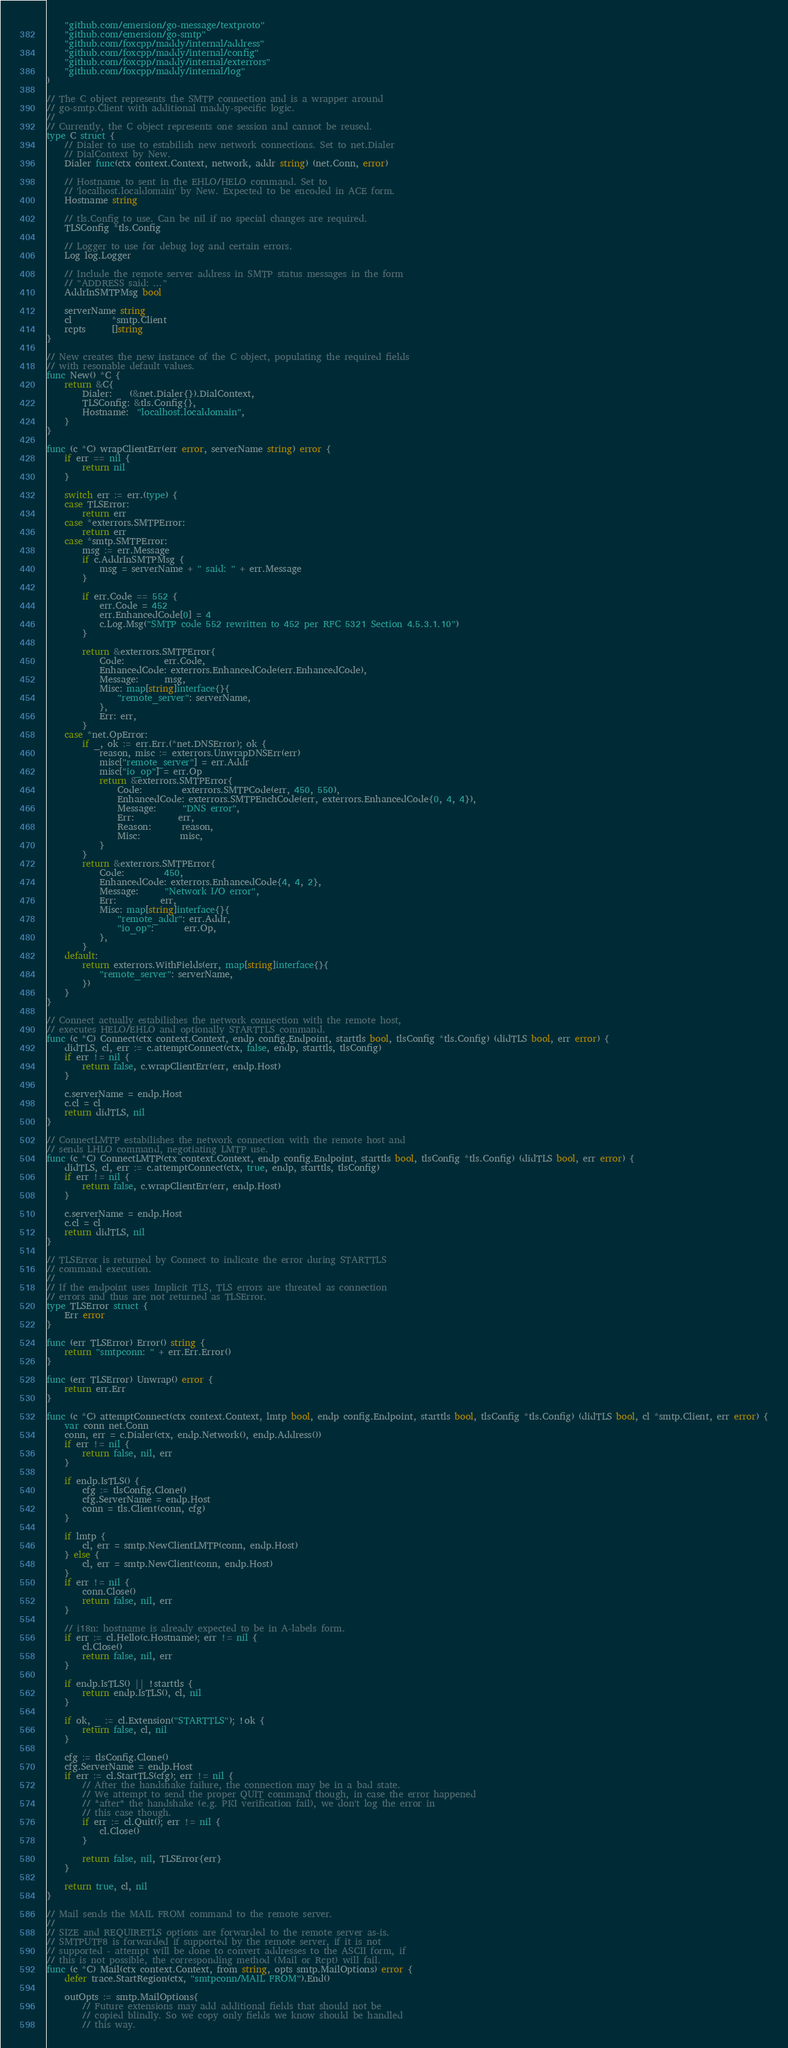<code> <loc_0><loc_0><loc_500><loc_500><_Go_>	"github.com/emersion/go-message/textproto"
	"github.com/emersion/go-smtp"
	"github.com/foxcpp/maddy/internal/address"
	"github.com/foxcpp/maddy/internal/config"
	"github.com/foxcpp/maddy/internal/exterrors"
	"github.com/foxcpp/maddy/internal/log"
)

// The C object represents the SMTP connection and is a wrapper around
// go-smtp.Client with additional maddy-specific logic.
//
// Currently, the C object represents one session and cannot be reused.
type C struct {
	// Dialer to use to estabilish new network connections. Set to net.Dialer
	// DialContext by New.
	Dialer func(ctx context.Context, network, addr string) (net.Conn, error)

	// Hostname to sent in the EHLO/HELO command. Set to
	// 'localhost.localdomain' by New. Expected to be encoded in ACE form.
	Hostname string

	// tls.Config to use. Can be nil if no special changes are required.
	TLSConfig *tls.Config

	// Logger to use for debug log and certain errors.
	Log log.Logger

	// Include the remote server address in SMTP status messages in the form
	// "ADDRESS said: ..."
	AddrInSMTPMsg bool

	serverName string
	cl         *smtp.Client
	rcpts      []string
}

// New creates the new instance of the C object, populating the required fields
// with resonable default values.
func New() *C {
	return &C{
		Dialer:    (&net.Dialer{}).DialContext,
		TLSConfig: &tls.Config{},
		Hostname:  "localhost.localdomain",
	}
}

func (c *C) wrapClientErr(err error, serverName string) error {
	if err == nil {
		return nil
	}

	switch err := err.(type) {
	case TLSError:
		return err
	case *exterrors.SMTPError:
		return err
	case *smtp.SMTPError:
		msg := err.Message
		if c.AddrInSMTPMsg {
			msg = serverName + " said: " + err.Message
		}

		if err.Code == 552 {
			err.Code = 452
			err.EnhancedCode[0] = 4
			c.Log.Msg("SMTP code 552 rewritten to 452 per RFC 5321 Section 4.5.3.1.10")
		}

		return &exterrors.SMTPError{
			Code:         err.Code,
			EnhancedCode: exterrors.EnhancedCode(err.EnhancedCode),
			Message:      msg,
			Misc: map[string]interface{}{
				"remote_server": serverName,
			},
			Err: err,
		}
	case *net.OpError:
		if _, ok := err.Err.(*net.DNSError); ok {
			reason, misc := exterrors.UnwrapDNSErr(err)
			misc["remote_server"] = err.Addr
			misc["io_op"] = err.Op
			return &exterrors.SMTPError{
				Code:         exterrors.SMTPCode(err, 450, 550),
				EnhancedCode: exterrors.SMTPEnchCode(err, exterrors.EnhancedCode{0, 4, 4}),
				Message:      "DNS error",
				Err:          err,
				Reason:       reason,
				Misc:         misc,
			}
		}
		return &exterrors.SMTPError{
			Code:         450,
			EnhancedCode: exterrors.EnhancedCode{4, 4, 2},
			Message:      "Network I/O error",
			Err:          err,
			Misc: map[string]interface{}{
				"remote_addr": err.Addr,
				"io_op":       err.Op,
			},
		}
	default:
		return exterrors.WithFields(err, map[string]interface{}{
			"remote_server": serverName,
		})
	}
}

// Connect actually estabilishes the network connection with the remote host,
// executes HELO/EHLO and optionally STARTTLS command.
func (c *C) Connect(ctx context.Context, endp config.Endpoint, starttls bool, tlsConfig *tls.Config) (didTLS bool, err error) {
	didTLS, cl, err := c.attemptConnect(ctx, false, endp, starttls, tlsConfig)
	if err != nil {
		return false, c.wrapClientErr(err, endp.Host)
	}

	c.serverName = endp.Host
	c.cl = cl
	return didTLS, nil
}

// ConnectLMTP estabilishes the network connection with the remote host and
// sends LHLO command, negotiating LMTP use.
func (c *C) ConnectLMTP(ctx context.Context, endp config.Endpoint, starttls bool, tlsConfig *tls.Config) (didTLS bool, err error) {
	didTLS, cl, err := c.attemptConnect(ctx, true, endp, starttls, tlsConfig)
	if err != nil {
		return false, c.wrapClientErr(err, endp.Host)
	}

	c.serverName = endp.Host
	c.cl = cl
	return didTLS, nil
}

// TLSError is returned by Connect to indicate the error during STARTTLS
// command execution.
//
// If the endpoint uses Implicit TLS, TLS errors are threated as connection
// errors and thus are not returned as TLSError.
type TLSError struct {
	Err error
}

func (err TLSError) Error() string {
	return "smtpconn: " + err.Err.Error()
}

func (err TLSError) Unwrap() error {
	return err.Err
}

func (c *C) attemptConnect(ctx context.Context, lmtp bool, endp config.Endpoint, starttls bool, tlsConfig *tls.Config) (didTLS bool, cl *smtp.Client, err error) {
	var conn net.Conn
	conn, err = c.Dialer(ctx, endp.Network(), endp.Address())
	if err != nil {
		return false, nil, err
	}

	if endp.IsTLS() {
		cfg := tlsConfig.Clone()
		cfg.ServerName = endp.Host
		conn = tls.Client(conn, cfg)
	}

	if lmtp {
		cl, err = smtp.NewClientLMTP(conn, endp.Host)
	} else {
		cl, err = smtp.NewClient(conn, endp.Host)
	}
	if err != nil {
		conn.Close()
		return false, nil, err
	}

	// i18n: hostname is already expected to be in A-labels form.
	if err := cl.Hello(c.Hostname); err != nil {
		cl.Close()
		return false, nil, err
	}

	if endp.IsTLS() || !starttls {
		return endp.IsTLS(), cl, nil
	}

	if ok, _ := cl.Extension("STARTTLS"); !ok {
		return false, cl, nil
	}

	cfg := tlsConfig.Clone()
	cfg.ServerName = endp.Host
	if err := cl.StartTLS(cfg); err != nil {
		// After the handshake failure, the connection may be in a bad state.
		// We attempt to send the proper QUIT command though, in case the error happened
		// *after* the handshake (e.g. PKI verification fail), we don't log the error in
		// this case though.
		if err := cl.Quit(); err != nil {
			cl.Close()
		}

		return false, nil, TLSError{err}
	}

	return true, cl, nil
}

// Mail sends the MAIL FROM command to the remote server.
//
// SIZE and REQUIRETLS options are forwarded to the remote server as-is.
// SMTPUTF8 is forwarded if supported by the remote server, if it is not
// supported - attempt will be done to convert addresses to the ASCII form, if
// this is not possible, the corresponding method (Mail or Rcpt) will fail.
func (c *C) Mail(ctx context.Context, from string, opts smtp.MailOptions) error {
	defer trace.StartRegion(ctx, "smtpconn/MAIL FROM").End()

	outOpts := smtp.MailOptions{
		// Future extensions may add additional fields that should not be
		// copied blindly. So we copy only fields we know should be handled
		// this way.
</code> 